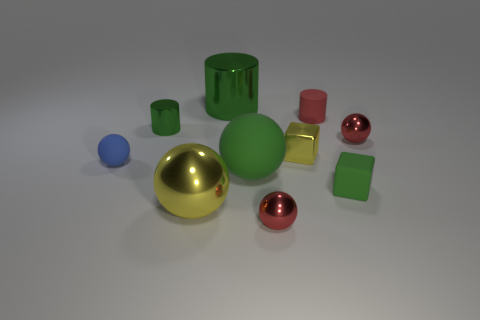What number of other objects are there of the same shape as the blue object?
Provide a succinct answer. 4. What color is the ball that is both behind the yellow metal ball and to the left of the big shiny cylinder?
Your response must be concise. Blue. What color is the matte cylinder?
Your answer should be compact. Red. Are the red cylinder and the green cylinder in front of the large metal cylinder made of the same material?
Provide a succinct answer. No. The big object that is made of the same material as the yellow ball is what shape?
Provide a short and direct response. Cylinder. What is the color of the matte sphere that is the same size as the yellow metallic cube?
Your answer should be compact. Blue. Is the size of the green shiny thing that is in front of the red cylinder the same as the blue matte sphere?
Offer a very short reply. Yes. Is the color of the large metallic ball the same as the large rubber sphere?
Make the answer very short. No. What number of small blue rubber balls are there?
Make the answer very short. 1. What number of blocks are either big matte objects or small green shiny things?
Your answer should be very brief. 0. 